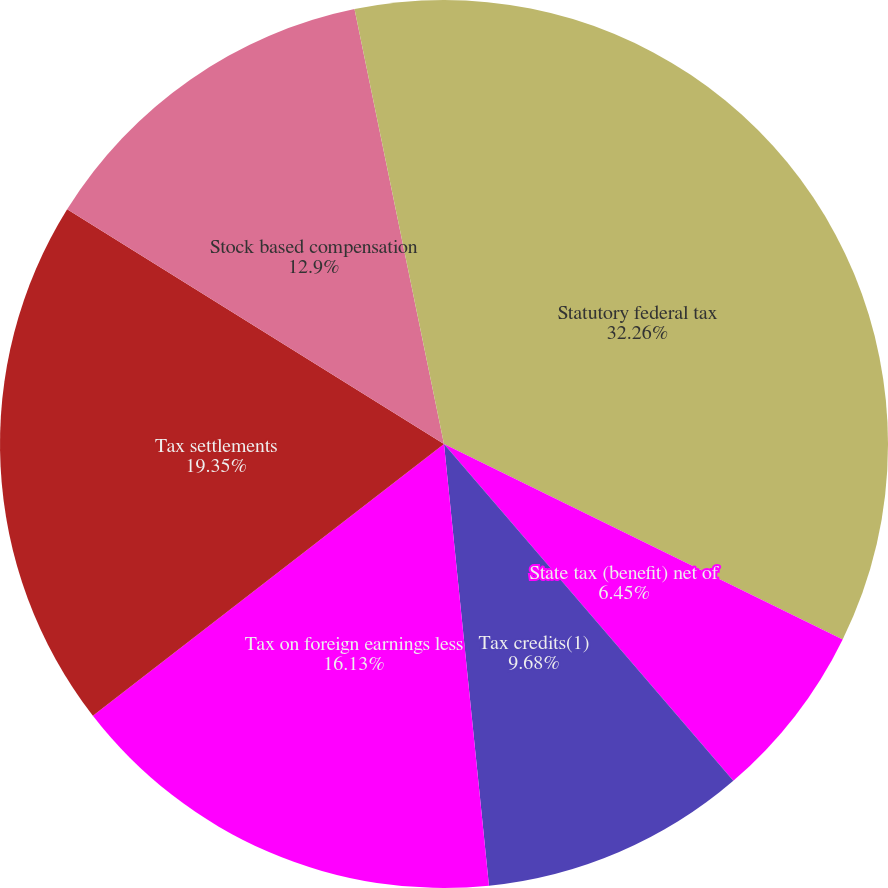<chart> <loc_0><loc_0><loc_500><loc_500><pie_chart><fcel>Statutory federal tax<fcel>State tax (benefit) net of<fcel>Tax credits(1)<fcel>Tax on foreign earnings less<fcel>Tax settlements<fcel>Stock based compensation<fcel>Changes in valuation allowance<fcel>Other<nl><fcel>32.25%<fcel>6.45%<fcel>9.68%<fcel>16.13%<fcel>19.35%<fcel>12.9%<fcel>0.0%<fcel>3.23%<nl></chart> 